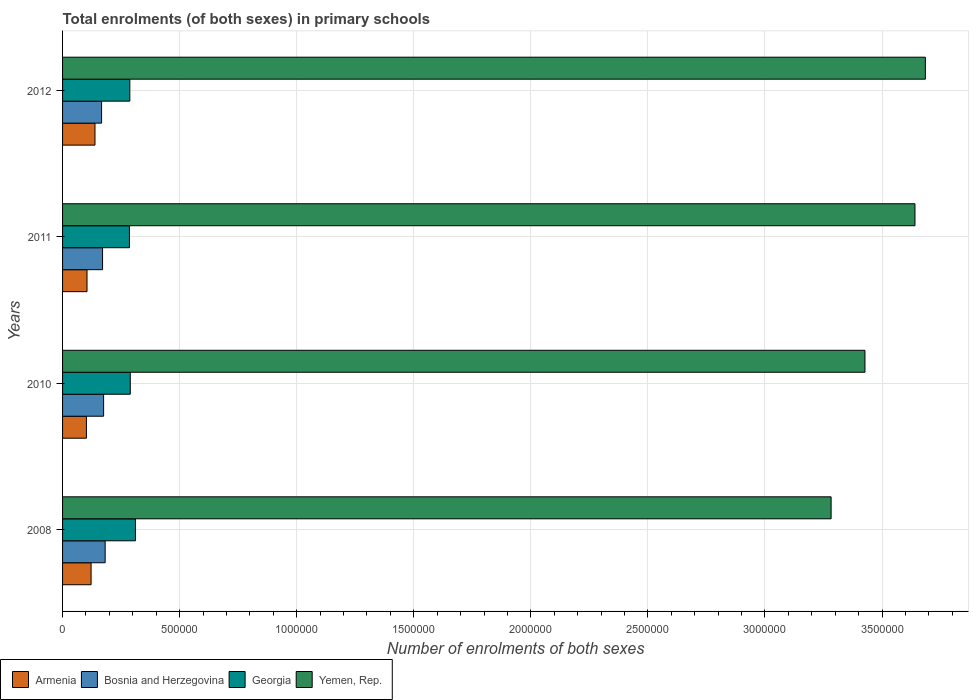How many different coloured bars are there?
Provide a succinct answer. 4. How many groups of bars are there?
Offer a terse response. 4. Are the number of bars per tick equal to the number of legend labels?
Give a very brief answer. Yes. How many bars are there on the 4th tick from the top?
Offer a terse response. 4. What is the label of the 4th group of bars from the top?
Keep it short and to the point. 2008. What is the number of enrolments in primary schools in Yemen, Rep. in 2011?
Make the answer very short. 3.64e+06. Across all years, what is the maximum number of enrolments in primary schools in Georgia?
Ensure brevity in your answer.  3.11e+05. Across all years, what is the minimum number of enrolments in primary schools in Georgia?
Make the answer very short. 2.86e+05. In which year was the number of enrolments in primary schools in Georgia minimum?
Provide a succinct answer. 2011. What is the total number of enrolments in primary schools in Armenia in the graph?
Provide a succinct answer. 4.67e+05. What is the difference between the number of enrolments in primary schools in Bosnia and Herzegovina in 2008 and that in 2012?
Your answer should be very brief. 1.53e+04. What is the difference between the number of enrolments in primary schools in Yemen, Rep. in 2008 and the number of enrolments in primary schools in Bosnia and Herzegovina in 2012?
Provide a short and direct response. 3.12e+06. What is the average number of enrolments in primary schools in Yemen, Rep. per year?
Provide a short and direct response. 3.51e+06. In the year 2012, what is the difference between the number of enrolments in primary schools in Armenia and number of enrolments in primary schools in Yemen, Rep.?
Your response must be concise. -3.55e+06. In how many years, is the number of enrolments in primary schools in Yemen, Rep. greater than 1700000 ?
Ensure brevity in your answer.  4. What is the ratio of the number of enrolments in primary schools in Georgia in 2008 to that in 2010?
Keep it short and to the point. 1.08. Is the number of enrolments in primary schools in Armenia in 2008 less than that in 2012?
Your response must be concise. Yes. What is the difference between the highest and the second highest number of enrolments in primary schools in Armenia?
Make the answer very short. 1.66e+04. What is the difference between the highest and the lowest number of enrolments in primary schools in Yemen, Rep.?
Make the answer very short. 4.02e+05. In how many years, is the number of enrolments in primary schools in Yemen, Rep. greater than the average number of enrolments in primary schools in Yemen, Rep. taken over all years?
Offer a terse response. 2. Is it the case that in every year, the sum of the number of enrolments in primary schools in Armenia and number of enrolments in primary schools in Bosnia and Herzegovina is greater than the sum of number of enrolments in primary schools in Yemen, Rep. and number of enrolments in primary schools in Georgia?
Provide a succinct answer. No. What does the 1st bar from the top in 2011 represents?
Your answer should be very brief. Yemen, Rep. What does the 2nd bar from the bottom in 2010 represents?
Make the answer very short. Bosnia and Herzegovina. How many bars are there?
Your answer should be compact. 16. Are all the bars in the graph horizontal?
Provide a short and direct response. Yes. How many years are there in the graph?
Give a very brief answer. 4. Are the values on the major ticks of X-axis written in scientific E-notation?
Offer a terse response. No. How many legend labels are there?
Offer a very short reply. 4. How are the legend labels stacked?
Ensure brevity in your answer.  Horizontal. What is the title of the graph?
Give a very brief answer. Total enrolments (of both sexes) in primary schools. What is the label or title of the X-axis?
Provide a short and direct response. Number of enrolments of both sexes. What is the Number of enrolments of both sexes in Armenia in 2008?
Keep it short and to the point. 1.22e+05. What is the Number of enrolments of both sexes of Bosnia and Herzegovina in 2008?
Your answer should be very brief. 1.82e+05. What is the Number of enrolments of both sexes in Georgia in 2008?
Ensure brevity in your answer.  3.11e+05. What is the Number of enrolments of both sexes of Yemen, Rep. in 2008?
Ensure brevity in your answer.  3.28e+06. What is the Number of enrolments of both sexes in Armenia in 2010?
Ensure brevity in your answer.  1.02e+05. What is the Number of enrolments of both sexes in Bosnia and Herzegovina in 2010?
Your answer should be compact. 1.75e+05. What is the Number of enrolments of both sexes of Georgia in 2010?
Ensure brevity in your answer.  2.89e+05. What is the Number of enrolments of both sexes in Yemen, Rep. in 2010?
Give a very brief answer. 3.43e+06. What is the Number of enrolments of both sexes of Armenia in 2011?
Your response must be concise. 1.04e+05. What is the Number of enrolments of both sexes of Bosnia and Herzegovina in 2011?
Offer a very short reply. 1.71e+05. What is the Number of enrolments of both sexes of Georgia in 2011?
Your response must be concise. 2.86e+05. What is the Number of enrolments of both sexes of Yemen, Rep. in 2011?
Provide a succinct answer. 3.64e+06. What is the Number of enrolments of both sexes in Armenia in 2012?
Ensure brevity in your answer.  1.38e+05. What is the Number of enrolments of both sexes of Bosnia and Herzegovina in 2012?
Provide a succinct answer. 1.67e+05. What is the Number of enrolments of both sexes in Georgia in 2012?
Your response must be concise. 2.87e+05. What is the Number of enrolments of both sexes in Yemen, Rep. in 2012?
Keep it short and to the point. 3.68e+06. Across all years, what is the maximum Number of enrolments of both sexes of Armenia?
Offer a very short reply. 1.38e+05. Across all years, what is the maximum Number of enrolments of both sexes in Bosnia and Herzegovina?
Ensure brevity in your answer.  1.82e+05. Across all years, what is the maximum Number of enrolments of both sexes in Georgia?
Provide a short and direct response. 3.11e+05. Across all years, what is the maximum Number of enrolments of both sexes in Yemen, Rep.?
Provide a short and direct response. 3.68e+06. Across all years, what is the minimum Number of enrolments of both sexes of Armenia?
Keep it short and to the point. 1.02e+05. Across all years, what is the minimum Number of enrolments of both sexes in Bosnia and Herzegovina?
Make the answer very short. 1.67e+05. Across all years, what is the minimum Number of enrolments of both sexes in Georgia?
Make the answer very short. 2.86e+05. Across all years, what is the minimum Number of enrolments of both sexes in Yemen, Rep.?
Your response must be concise. 3.28e+06. What is the total Number of enrolments of both sexes in Armenia in the graph?
Provide a short and direct response. 4.67e+05. What is the total Number of enrolments of both sexes in Bosnia and Herzegovina in the graph?
Offer a very short reply. 6.95e+05. What is the total Number of enrolments of both sexes of Georgia in the graph?
Make the answer very short. 1.17e+06. What is the total Number of enrolments of both sexes of Yemen, Rep. in the graph?
Provide a short and direct response. 1.40e+07. What is the difference between the Number of enrolments of both sexes in Armenia in 2008 and that in 2010?
Your response must be concise. 2.00e+04. What is the difference between the Number of enrolments of both sexes in Bosnia and Herzegovina in 2008 and that in 2010?
Give a very brief answer. 6646. What is the difference between the Number of enrolments of both sexes in Georgia in 2008 and that in 2010?
Provide a short and direct response. 2.21e+04. What is the difference between the Number of enrolments of both sexes of Yemen, Rep. in 2008 and that in 2010?
Provide a short and direct response. -1.45e+05. What is the difference between the Number of enrolments of both sexes in Armenia in 2008 and that in 2011?
Your answer should be compact. 1.74e+04. What is the difference between the Number of enrolments of both sexes of Bosnia and Herzegovina in 2008 and that in 2011?
Ensure brevity in your answer.  1.11e+04. What is the difference between the Number of enrolments of both sexes of Georgia in 2008 and that in 2011?
Give a very brief answer. 2.57e+04. What is the difference between the Number of enrolments of both sexes in Yemen, Rep. in 2008 and that in 2011?
Your answer should be compact. -3.58e+05. What is the difference between the Number of enrolments of both sexes in Armenia in 2008 and that in 2012?
Your answer should be compact. -1.66e+04. What is the difference between the Number of enrolments of both sexes of Bosnia and Herzegovina in 2008 and that in 2012?
Ensure brevity in your answer.  1.53e+04. What is the difference between the Number of enrolments of both sexes in Georgia in 2008 and that in 2012?
Your response must be concise. 2.40e+04. What is the difference between the Number of enrolments of both sexes of Yemen, Rep. in 2008 and that in 2012?
Your answer should be very brief. -4.02e+05. What is the difference between the Number of enrolments of both sexes of Armenia in 2010 and that in 2011?
Provide a short and direct response. -2624. What is the difference between the Number of enrolments of both sexes of Bosnia and Herzegovina in 2010 and that in 2011?
Your answer should be very brief. 4429. What is the difference between the Number of enrolments of both sexes in Georgia in 2010 and that in 2011?
Make the answer very short. 3598. What is the difference between the Number of enrolments of both sexes in Yemen, Rep. in 2010 and that in 2011?
Keep it short and to the point. -2.14e+05. What is the difference between the Number of enrolments of both sexes in Armenia in 2010 and that in 2012?
Your answer should be very brief. -3.67e+04. What is the difference between the Number of enrolments of both sexes in Bosnia and Herzegovina in 2010 and that in 2012?
Your answer should be very brief. 8651. What is the difference between the Number of enrolments of both sexes of Georgia in 2010 and that in 2012?
Your answer should be compact. 1892. What is the difference between the Number of enrolments of both sexes in Yemen, Rep. in 2010 and that in 2012?
Provide a succinct answer. -2.58e+05. What is the difference between the Number of enrolments of both sexes in Armenia in 2011 and that in 2012?
Offer a terse response. -3.40e+04. What is the difference between the Number of enrolments of both sexes of Bosnia and Herzegovina in 2011 and that in 2012?
Your response must be concise. 4222. What is the difference between the Number of enrolments of both sexes of Georgia in 2011 and that in 2012?
Give a very brief answer. -1706. What is the difference between the Number of enrolments of both sexes in Yemen, Rep. in 2011 and that in 2012?
Offer a very short reply. -4.44e+04. What is the difference between the Number of enrolments of both sexes of Armenia in 2008 and the Number of enrolments of both sexes of Bosnia and Herzegovina in 2010?
Ensure brevity in your answer.  -5.34e+04. What is the difference between the Number of enrolments of both sexes of Armenia in 2008 and the Number of enrolments of both sexes of Georgia in 2010?
Keep it short and to the point. -1.67e+05. What is the difference between the Number of enrolments of both sexes of Armenia in 2008 and the Number of enrolments of both sexes of Yemen, Rep. in 2010?
Your answer should be very brief. -3.31e+06. What is the difference between the Number of enrolments of both sexes of Bosnia and Herzegovina in 2008 and the Number of enrolments of both sexes of Georgia in 2010?
Provide a short and direct response. -1.07e+05. What is the difference between the Number of enrolments of both sexes in Bosnia and Herzegovina in 2008 and the Number of enrolments of both sexes in Yemen, Rep. in 2010?
Make the answer very short. -3.25e+06. What is the difference between the Number of enrolments of both sexes in Georgia in 2008 and the Number of enrolments of both sexes in Yemen, Rep. in 2010?
Keep it short and to the point. -3.12e+06. What is the difference between the Number of enrolments of both sexes of Armenia in 2008 and the Number of enrolments of both sexes of Bosnia and Herzegovina in 2011?
Keep it short and to the point. -4.90e+04. What is the difference between the Number of enrolments of both sexes in Armenia in 2008 and the Number of enrolments of both sexes in Georgia in 2011?
Provide a succinct answer. -1.64e+05. What is the difference between the Number of enrolments of both sexes in Armenia in 2008 and the Number of enrolments of both sexes in Yemen, Rep. in 2011?
Your response must be concise. -3.52e+06. What is the difference between the Number of enrolments of both sexes of Bosnia and Herzegovina in 2008 and the Number of enrolments of both sexes of Georgia in 2011?
Keep it short and to the point. -1.04e+05. What is the difference between the Number of enrolments of both sexes in Bosnia and Herzegovina in 2008 and the Number of enrolments of both sexes in Yemen, Rep. in 2011?
Keep it short and to the point. -3.46e+06. What is the difference between the Number of enrolments of both sexes of Georgia in 2008 and the Number of enrolments of both sexes of Yemen, Rep. in 2011?
Your answer should be compact. -3.33e+06. What is the difference between the Number of enrolments of both sexes in Armenia in 2008 and the Number of enrolments of both sexes in Bosnia and Herzegovina in 2012?
Your answer should be very brief. -4.48e+04. What is the difference between the Number of enrolments of both sexes of Armenia in 2008 and the Number of enrolments of both sexes of Georgia in 2012?
Keep it short and to the point. -1.65e+05. What is the difference between the Number of enrolments of both sexes of Armenia in 2008 and the Number of enrolments of both sexes of Yemen, Rep. in 2012?
Provide a succinct answer. -3.56e+06. What is the difference between the Number of enrolments of both sexes in Bosnia and Herzegovina in 2008 and the Number of enrolments of both sexes in Georgia in 2012?
Your answer should be compact. -1.05e+05. What is the difference between the Number of enrolments of both sexes of Bosnia and Herzegovina in 2008 and the Number of enrolments of both sexes of Yemen, Rep. in 2012?
Offer a very short reply. -3.50e+06. What is the difference between the Number of enrolments of both sexes of Georgia in 2008 and the Number of enrolments of both sexes of Yemen, Rep. in 2012?
Provide a succinct answer. -3.37e+06. What is the difference between the Number of enrolments of both sexes in Armenia in 2010 and the Number of enrolments of both sexes in Bosnia and Herzegovina in 2011?
Offer a terse response. -6.90e+04. What is the difference between the Number of enrolments of both sexes of Armenia in 2010 and the Number of enrolments of both sexes of Georgia in 2011?
Keep it short and to the point. -1.84e+05. What is the difference between the Number of enrolments of both sexes of Armenia in 2010 and the Number of enrolments of both sexes of Yemen, Rep. in 2011?
Provide a succinct answer. -3.54e+06. What is the difference between the Number of enrolments of both sexes in Bosnia and Herzegovina in 2010 and the Number of enrolments of both sexes in Georgia in 2011?
Your answer should be compact. -1.10e+05. What is the difference between the Number of enrolments of both sexes in Bosnia and Herzegovina in 2010 and the Number of enrolments of both sexes in Yemen, Rep. in 2011?
Offer a terse response. -3.47e+06. What is the difference between the Number of enrolments of both sexes in Georgia in 2010 and the Number of enrolments of both sexes in Yemen, Rep. in 2011?
Offer a very short reply. -3.35e+06. What is the difference between the Number of enrolments of both sexes of Armenia in 2010 and the Number of enrolments of both sexes of Bosnia and Herzegovina in 2012?
Make the answer very short. -6.48e+04. What is the difference between the Number of enrolments of both sexes of Armenia in 2010 and the Number of enrolments of both sexes of Georgia in 2012?
Offer a very short reply. -1.85e+05. What is the difference between the Number of enrolments of both sexes in Armenia in 2010 and the Number of enrolments of both sexes in Yemen, Rep. in 2012?
Offer a terse response. -3.58e+06. What is the difference between the Number of enrolments of both sexes of Bosnia and Herzegovina in 2010 and the Number of enrolments of both sexes of Georgia in 2012?
Offer a very short reply. -1.12e+05. What is the difference between the Number of enrolments of both sexes of Bosnia and Herzegovina in 2010 and the Number of enrolments of both sexes of Yemen, Rep. in 2012?
Provide a succinct answer. -3.51e+06. What is the difference between the Number of enrolments of both sexes of Georgia in 2010 and the Number of enrolments of both sexes of Yemen, Rep. in 2012?
Give a very brief answer. -3.40e+06. What is the difference between the Number of enrolments of both sexes of Armenia in 2011 and the Number of enrolments of both sexes of Bosnia and Herzegovina in 2012?
Offer a very short reply. -6.22e+04. What is the difference between the Number of enrolments of both sexes of Armenia in 2011 and the Number of enrolments of both sexes of Georgia in 2012?
Your answer should be compact. -1.83e+05. What is the difference between the Number of enrolments of both sexes in Armenia in 2011 and the Number of enrolments of both sexes in Yemen, Rep. in 2012?
Provide a short and direct response. -3.58e+06. What is the difference between the Number of enrolments of both sexes of Bosnia and Herzegovina in 2011 and the Number of enrolments of both sexes of Georgia in 2012?
Offer a very short reply. -1.16e+05. What is the difference between the Number of enrolments of both sexes of Bosnia and Herzegovina in 2011 and the Number of enrolments of both sexes of Yemen, Rep. in 2012?
Your answer should be very brief. -3.51e+06. What is the difference between the Number of enrolments of both sexes of Georgia in 2011 and the Number of enrolments of both sexes of Yemen, Rep. in 2012?
Keep it short and to the point. -3.40e+06. What is the average Number of enrolments of both sexes in Armenia per year?
Provide a succinct answer. 1.17e+05. What is the average Number of enrolments of both sexes of Bosnia and Herzegovina per year?
Keep it short and to the point. 1.74e+05. What is the average Number of enrolments of both sexes of Georgia per year?
Give a very brief answer. 2.93e+05. What is the average Number of enrolments of both sexes in Yemen, Rep. per year?
Your answer should be very brief. 3.51e+06. In the year 2008, what is the difference between the Number of enrolments of both sexes of Armenia and Number of enrolments of both sexes of Bosnia and Herzegovina?
Offer a terse response. -6.01e+04. In the year 2008, what is the difference between the Number of enrolments of both sexes of Armenia and Number of enrolments of both sexes of Georgia?
Provide a succinct answer. -1.89e+05. In the year 2008, what is the difference between the Number of enrolments of both sexes in Armenia and Number of enrolments of both sexes in Yemen, Rep.?
Offer a terse response. -3.16e+06. In the year 2008, what is the difference between the Number of enrolments of both sexes in Bosnia and Herzegovina and Number of enrolments of both sexes in Georgia?
Provide a succinct answer. -1.29e+05. In the year 2008, what is the difference between the Number of enrolments of both sexes of Bosnia and Herzegovina and Number of enrolments of both sexes of Yemen, Rep.?
Give a very brief answer. -3.10e+06. In the year 2008, what is the difference between the Number of enrolments of both sexes of Georgia and Number of enrolments of both sexes of Yemen, Rep.?
Your response must be concise. -2.97e+06. In the year 2010, what is the difference between the Number of enrolments of both sexes in Armenia and Number of enrolments of both sexes in Bosnia and Herzegovina?
Make the answer very short. -7.35e+04. In the year 2010, what is the difference between the Number of enrolments of both sexes of Armenia and Number of enrolments of both sexes of Georgia?
Make the answer very short. -1.87e+05. In the year 2010, what is the difference between the Number of enrolments of both sexes in Armenia and Number of enrolments of both sexes in Yemen, Rep.?
Provide a short and direct response. -3.33e+06. In the year 2010, what is the difference between the Number of enrolments of both sexes in Bosnia and Herzegovina and Number of enrolments of both sexes in Georgia?
Offer a very short reply. -1.14e+05. In the year 2010, what is the difference between the Number of enrolments of both sexes of Bosnia and Herzegovina and Number of enrolments of both sexes of Yemen, Rep.?
Provide a short and direct response. -3.25e+06. In the year 2010, what is the difference between the Number of enrolments of both sexes in Georgia and Number of enrolments of both sexes in Yemen, Rep.?
Offer a very short reply. -3.14e+06. In the year 2011, what is the difference between the Number of enrolments of both sexes of Armenia and Number of enrolments of both sexes of Bosnia and Herzegovina?
Your response must be concise. -6.64e+04. In the year 2011, what is the difference between the Number of enrolments of both sexes in Armenia and Number of enrolments of both sexes in Georgia?
Offer a terse response. -1.81e+05. In the year 2011, what is the difference between the Number of enrolments of both sexes in Armenia and Number of enrolments of both sexes in Yemen, Rep.?
Give a very brief answer. -3.54e+06. In the year 2011, what is the difference between the Number of enrolments of both sexes of Bosnia and Herzegovina and Number of enrolments of both sexes of Georgia?
Give a very brief answer. -1.15e+05. In the year 2011, what is the difference between the Number of enrolments of both sexes in Bosnia and Herzegovina and Number of enrolments of both sexes in Yemen, Rep.?
Ensure brevity in your answer.  -3.47e+06. In the year 2011, what is the difference between the Number of enrolments of both sexes of Georgia and Number of enrolments of both sexes of Yemen, Rep.?
Keep it short and to the point. -3.36e+06. In the year 2012, what is the difference between the Number of enrolments of both sexes in Armenia and Number of enrolments of both sexes in Bosnia and Herzegovina?
Your answer should be very brief. -2.82e+04. In the year 2012, what is the difference between the Number of enrolments of both sexes of Armenia and Number of enrolments of both sexes of Georgia?
Offer a very short reply. -1.49e+05. In the year 2012, what is the difference between the Number of enrolments of both sexes of Armenia and Number of enrolments of both sexes of Yemen, Rep.?
Give a very brief answer. -3.55e+06. In the year 2012, what is the difference between the Number of enrolments of both sexes of Bosnia and Herzegovina and Number of enrolments of both sexes of Georgia?
Provide a short and direct response. -1.21e+05. In the year 2012, what is the difference between the Number of enrolments of both sexes of Bosnia and Herzegovina and Number of enrolments of both sexes of Yemen, Rep.?
Provide a short and direct response. -3.52e+06. In the year 2012, what is the difference between the Number of enrolments of both sexes of Georgia and Number of enrolments of both sexes of Yemen, Rep.?
Give a very brief answer. -3.40e+06. What is the ratio of the Number of enrolments of both sexes in Armenia in 2008 to that in 2010?
Offer a very short reply. 1.2. What is the ratio of the Number of enrolments of both sexes of Bosnia and Herzegovina in 2008 to that in 2010?
Ensure brevity in your answer.  1.04. What is the ratio of the Number of enrolments of both sexes in Georgia in 2008 to that in 2010?
Give a very brief answer. 1.08. What is the ratio of the Number of enrolments of both sexes in Yemen, Rep. in 2008 to that in 2010?
Offer a very short reply. 0.96. What is the ratio of the Number of enrolments of both sexes of Armenia in 2008 to that in 2011?
Make the answer very short. 1.17. What is the ratio of the Number of enrolments of both sexes in Bosnia and Herzegovina in 2008 to that in 2011?
Provide a succinct answer. 1.06. What is the ratio of the Number of enrolments of both sexes of Georgia in 2008 to that in 2011?
Your response must be concise. 1.09. What is the ratio of the Number of enrolments of both sexes in Yemen, Rep. in 2008 to that in 2011?
Ensure brevity in your answer.  0.9. What is the ratio of the Number of enrolments of both sexes of Armenia in 2008 to that in 2012?
Your response must be concise. 0.88. What is the ratio of the Number of enrolments of both sexes in Bosnia and Herzegovina in 2008 to that in 2012?
Make the answer very short. 1.09. What is the ratio of the Number of enrolments of both sexes of Georgia in 2008 to that in 2012?
Provide a short and direct response. 1.08. What is the ratio of the Number of enrolments of both sexes of Yemen, Rep. in 2008 to that in 2012?
Offer a terse response. 0.89. What is the ratio of the Number of enrolments of both sexes of Armenia in 2010 to that in 2011?
Offer a terse response. 0.97. What is the ratio of the Number of enrolments of both sexes in Bosnia and Herzegovina in 2010 to that in 2011?
Make the answer very short. 1.03. What is the ratio of the Number of enrolments of both sexes in Georgia in 2010 to that in 2011?
Provide a short and direct response. 1.01. What is the ratio of the Number of enrolments of both sexes in Yemen, Rep. in 2010 to that in 2011?
Ensure brevity in your answer.  0.94. What is the ratio of the Number of enrolments of both sexes of Armenia in 2010 to that in 2012?
Give a very brief answer. 0.74. What is the ratio of the Number of enrolments of both sexes of Bosnia and Herzegovina in 2010 to that in 2012?
Offer a very short reply. 1.05. What is the ratio of the Number of enrolments of both sexes in Georgia in 2010 to that in 2012?
Your response must be concise. 1.01. What is the ratio of the Number of enrolments of both sexes of Armenia in 2011 to that in 2012?
Your answer should be compact. 0.75. What is the ratio of the Number of enrolments of both sexes of Bosnia and Herzegovina in 2011 to that in 2012?
Provide a succinct answer. 1.03. What is the ratio of the Number of enrolments of both sexes of Yemen, Rep. in 2011 to that in 2012?
Provide a short and direct response. 0.99. What is the difference between the highest and the second highest Number of enrolments of both sexes of Armenia?
Offer a terse response. 1.66e+04. What is the difference between the highest and the second highest Number of enrolments of both sexes in Bosnia and Herzegovina?
Offer a terse response. 6646. What is the difference between the highest and the second highest Number of enrolments of both sexes in Georgia?
Your response must be concise. 2.21e+04. What is the difference between the highest and the second highest Number of enrolments of both sexes of Yemen, Rep.?
Your answer should be compact. 4.44e+04. What is the difference between the highest and the lowest Number of enrolments of both sexes of Armenia?
Provide a short and direct response. 3.67e+04. What is the difference between the highest and the lowest Number of enrolments of both sexes in Bosnia and Herzegovina?
Offer a terse response. 1.53e+04. What is the difference between the highest and the lowest Number of enrolments of both sexes in Georgia?
Make the answer very short. 2.57e+04. What is the difference between the highest and the lowest Number of enrolments of both sexes in Yemen, Rep.?
Offer a very short reply. 4.02e+05. 